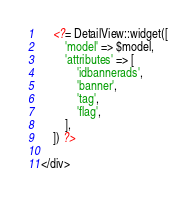Convert code to text. <code><loc_0><loc_0><loc_500><loc_500><_PHP_>
    <?= DetailView::widget([
        'model' => $model,
        'attributes' => [
            'idbannerads',
            'banner',
            'tag',
            'flag',
        ],
    ]) ?>

</div>
</code> 